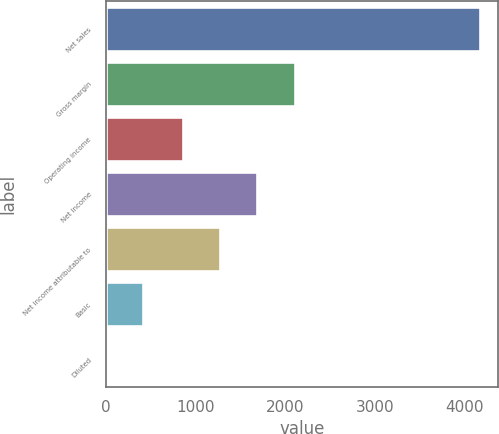Convert chart to OTSL. <chart><loc_0><loc_0><loc_500><loc_500><bar_chart><fcel>Net sales<fcel>Gross margin<fcel>Operating income<fcel>Net income<fcel>Net income attributable to<fcel>Basic<fcel>Diluted<nl><fcel>4166<fcel>2104.56<fcel>855<fcel>1688.04<fcel>1271.52<fcel>417.3<fcel>0.78<nl></chart> 